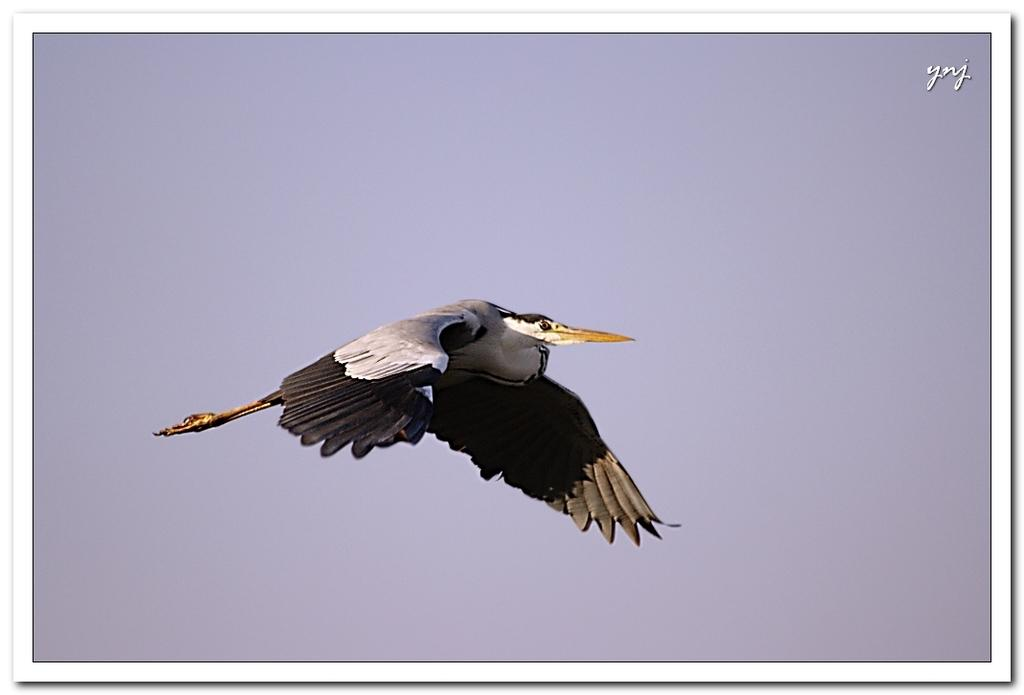What type of animal is in the image? There is a bird in the image. Can you describe the bird's coloring? The bird has white and brown colors. What can be seen in the background of the image? The sky is visible in the background of the image. What color is the sky in the background? The sky in the background is white. How many cents are visible in the image? There are no cents present in the image. What type of fan can be seen in the image? There is no fan present in the image. 